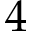<formula> <loc_0><loc_0><loc_500><loc_500>4</formula> 